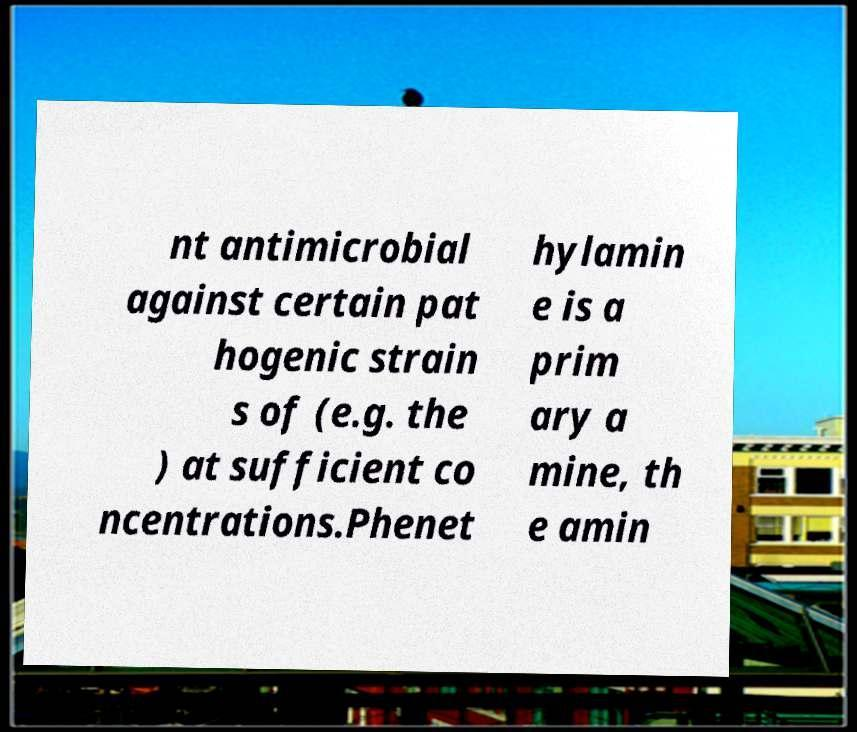Could you assist in decoding the text presented in this image and type it out clearly? nt antimicrobial against certain pat hogenic strain s of (e.g. the ) at sufficient co ncentrations.Phenet hylamin e is a prim ary a mine, th e amin 